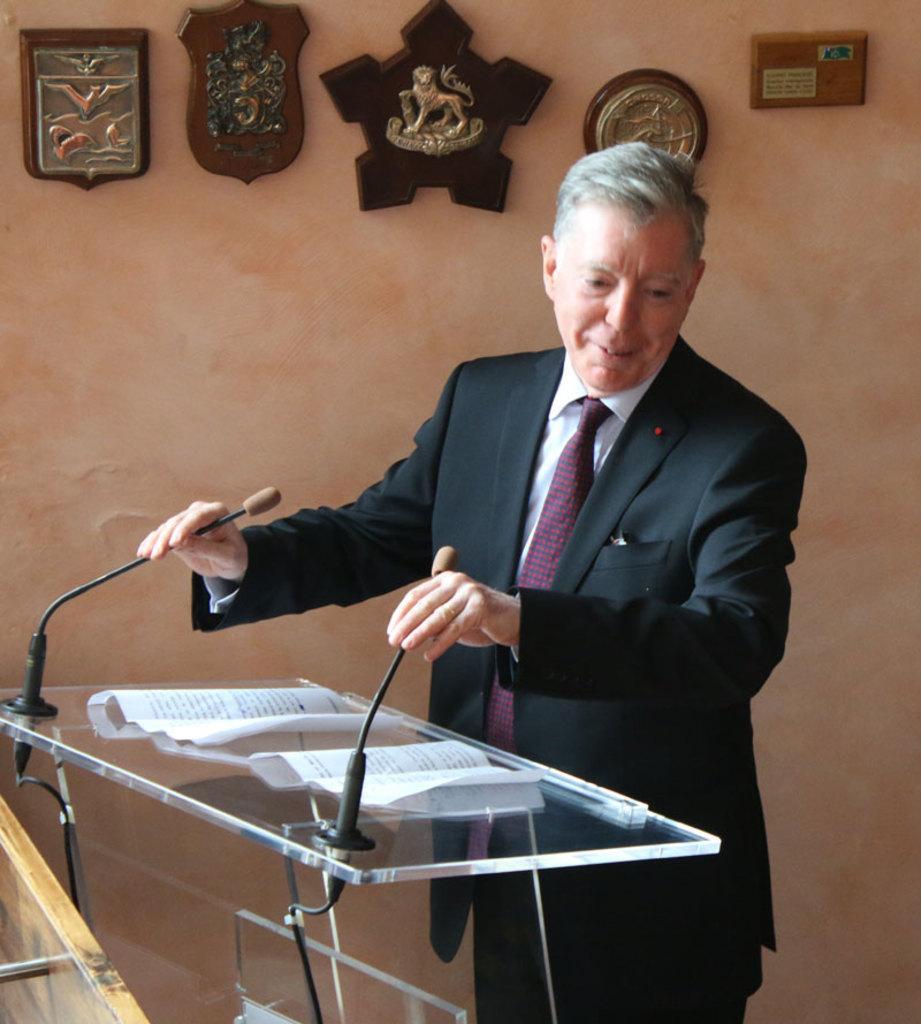How would you summarize this image in a sentence or two? In this image the person is standing in front of the podium. On podium there is a mic and a papers. At the back side there are some frames. 